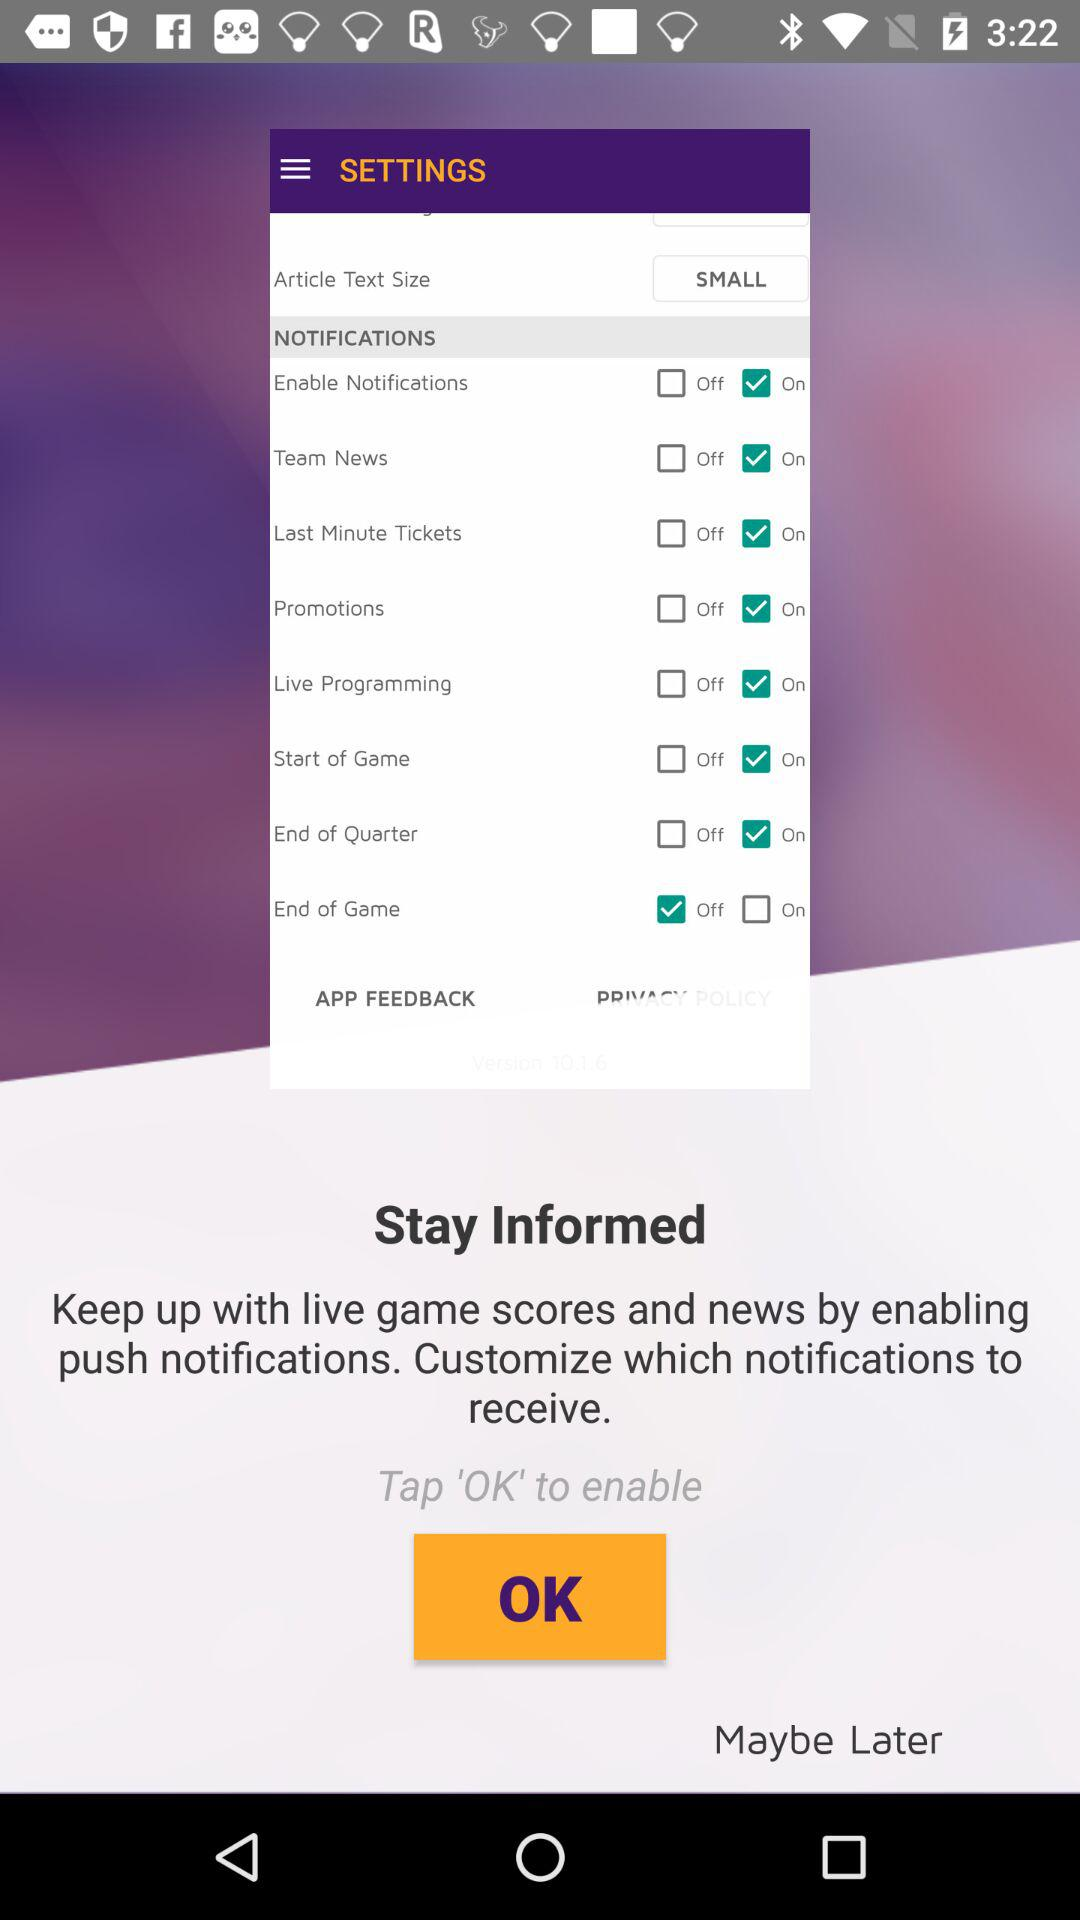What is the size of the article text size? The article text size is "SMALL". 